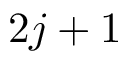Convert formula to latex. <formula><loc_0><loc_0><loc_500><loc_500>2 j + 1</formula> 